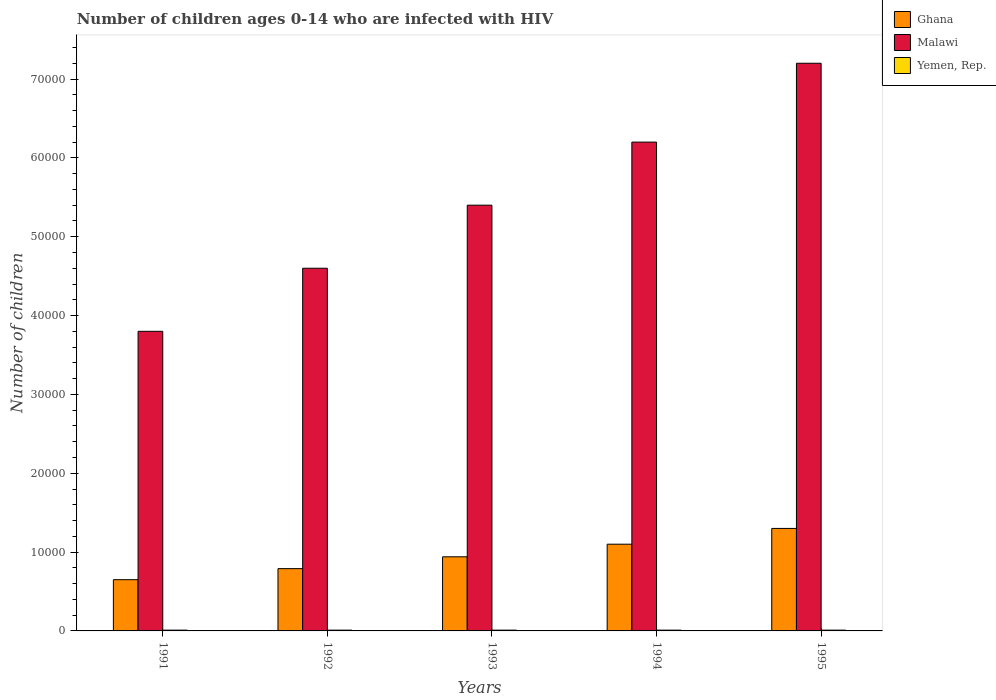How many different coloured bars are there?
Ensure brevity in your answer.  3. Are the number of bars per tick equal to the number of legend labels?
Keep it short and to the point. Yes. What is the number of HIV infected children in Yemen, Rep. in 1993?
Provide a succinct answer. 100. Across all years, what is the maximum number of HIV infected children in Yemen, Rep.?
Ensure brevity in your answer.  100. Across all years, what is the minimum number of HIV infected children in Yemen, Rep.?
Offer a very short reply. 100. In which year was the number of HIV infected children in Yemen, Rep. maximum?
Keep it short and to the point. 1991. What is the total number of HIV infected children in Ghana in the graph?
Provide a short and direct response. 4.78e+04. What is the difference between the number of HIV infected children in Yemen, Rep. in 1992 and the number of HIV infected children in Malawi in 1994?
Offer a terse response. -6.19e+04. What is the average number of HIV infected children in Malawi per year?
Your answer should be very brief. 5.44e+04. In the year 1993, what is the difference between the number of HIV infected children in Malawi and number of HIV infected children in Yemen, Rep.?
Your answer should be compact. 5.39e+04. What is the ratio of the number of HIV infected children in Ghana in 1993 to that in 1994?
Ensure brevity in your answer.  0.85. Is the number of HIV infected children in Yemen, Rep. in 1992 less than that in 1995?
Provide a succinct answer. No. Is the difference between the number of HIV infected children in Malawi in 1991 and 1993 greater than the difference between the number of HIV infected children in Yemen, Rep. in 1991 and 1993?
Keep it short and to the point. No. What is the difference between the highest and the second highest number of HIV infected children in Malawi?
Make the answer very short. 10000. Is the sum of the number of HIV infected children in Malawi in 1994 and 1995 greater than the maximum number of HIV infected children in Yemen, Rep. across all years?
Your answer should be very brief. Yes. What does the 2nd bar from the right in 1991 represents?
Make the answer very short. Malawi. Are all the bars in the graph horizontal?
Provide a short and direct response. No. How many years are there in the graph?
Keep it short and to the point. 5. Are the values on the major ticks of Y-axis written in scientific E-notation?
Your answer should be compact. No. Does the graph contain any zero values?
Ensure brevity in your answer.  No. How many legend labels are there?
Offer a terse response. 3. How are the legend labels stacked?
Provide a succinct answer. Vertical. What is the title of the graph?
Offer a terse response. Number of children ages 0-14 who are infected with HIV. What is the label or title of the Y-axis?
Your response must be concise. Number of children. What is the Number of children in Ghana in 1991?
Your answer should be very brief. 6500. What is the Number of children of Malawi in 1991?
Your answer should be compact. 3.80e+04. What is the Number of children of Yemen, Rep. in 1991?
Ensure brevity in your answer.  100. What is the Number of children of Ghana in 1992?
Ensure brevity in your answer.  7900. What is the Number of children of Malawi in 1992?
Offer a terse response. 4.60e+04. What is the Number of children in Yemen, Rep. in 1992?
Give a very brief answer. 100. What is the Number of children of Ghana in 1993?
Your answer should be very brief. 9400. What is the Number of children in Malawi in 1993?
Give a very brief answer. 5.40e+04. What is the Number of children in Yemen, Rep. in 1993?
Keep it short and to the point. 100. What is the Number of children in Ghana in 1994?
Ensure brevity in your answer.  1.10e+04. What is the Number of children of Malawi in 1994?
Ensure brevity in your answer.  6.20e+04. What is the Number of children of Ghana in 1995?
Your answer should be compact. 1.30e+04. What is the Number of children in Malawi in 1995?
Keep it short and to the point. 7.20e+04. What is the Number of children in Yemen, Rep. in 1995?
Keep it short and to the point. 100. Across all years, what is the maximum Number of children of Ghana?
Your answer should be compact. 1.30e+04. Across all years, what is the maximum Number of children of Malawi?
Make the answer very short. 7.20e+04. Across all years, what is the minimum Number of children of Ghana?
Offer a terse response. 6500. Across all years, what is the minimum Number of children in Malawi?
Provide a succinct answer. 3.80e+04. Across all years, what is the minimum Number of children of Yemen, Rep.?
Provide a short and direct response. 100. What is the total Number of children of Ghana in the graph?
Your response must be concise. 4.78e+04. What is the total Number of children in Malawi in the graph?
Provide a short and direct response. 2.72e+05. What is the total Number of children of Yemen, Rep. in the graph?
Provide a succinct answer. 500. What is the difference between the Number of children in Ghana in 1991 and that in 1992?
Give a very brief answer. -1400. What is the difference between the Number of children in Malawi in 1991 and that in 1992?
Provide a short and direct response. -8000. What is the difference between the Number of children in Ghana in 1991 and that in 1993?
Your answer should be compact. -2900. What is the difference between the Number of children of Malawi in 1991 and that in 1993?
Your answer should be very brief. -1.60e+04. What is the difference between the Number of children of Ghana in 1991 and that in 1994?
Provide a short and direct response. -4500. What is the difference between the Number of children of Malawi in 1991 and that in 1994?
Offer a terse response. -2.40e+04. What is the difference between the Number of children of Yemen, Rep. in 1991 and that in 1994?
Your answer should be very brief. 0. What is the difference between the Number of children of Ghana in 1991 and that in 1995?
Your answer should be compact. -6500. What is the difference between the Number of children in Malawi in 1991 and that in 1995?
Make the answer very short. -3.40e+04. What is the difference between the Number of children in Ghana in 1992 and that in 1993?
Offer a very short reply. -1500. What is the difference between the Number of children of Malawi in 1992 and that in 1993?
Your response must be concise. -8000. What is the difference between the Number of children of Yemen, Rep. in 1992 and that in 1993?
Provide a short and direct response. 0. What is the difference between the Number of children of Ghana in 1992 and that in 1994?
Your answer should be compact. -3100. What is the difference between the Number of children in Malawi in 1992 and that in 1994?
Provide a short and direct response. -1.60e+04. What is the difference between the Number of children of Yemen, Rep. in 1992 and that in 1994?
Give a very brief answer. 0. What is the difference between the Number of children in Ghana in 1992 and that in 1995?
Provide a short and direct response. -5100. What is the difference between the Number of children of Malawi in 1992 and that in 1995?
Your response must be concise. -2.60e+04. What is the difference between the Number of children of Yemen, Rep. in 1992 and that in 1995?
Ensure brevity in your answer.  0. What is the difference between the Number of children of Ghana in 1993 and that in 1994?
Provide a short and direct response. -1600. What is the difference between the Number of children in Malawi in 1993 and that in 1994?
Your answer should be compact. -8000. What is the difference between the Number of children in Yemen, Rep. in 1993 and that in 1994?
Give a very brief answer. 0. What is the difference between the Number of children in Ghana in 1993 and that in 1995?
Ensure brevity in your answer.  -3600. What is the difference between the Number of children in Malawi in 1993 and that in 1995?
Keep it short and to the point. -1.80e+04. What is the difference between the Number of children of Yemen, Rep. in 1993 and that in 1995?
Ensure brevity in your answer.  0. What is the difference between the Number of children of Ghana in 1994 and that in 1995?
Offer a terse response. -2000. What is the difference between the Number of children in Malawi in 1994 and that in 1995?
Provide a succinct answer. -10000. What is the difference between the Number of children in Yemen, Rep. in 1994 and that in 1995?
Keep it short and to the point. 0. What is the difference between the Number of children of Ghana in 1991 and the Number of children of Malawi in 1992?
Keep it short and to the point. -3.95e+04. What is the difference between the Number of children in Ghana in 1991 and the Number of children in Yemen, Rep. in 1992?
Make the answer very short. 6400. What is the difference between the Number of children in Malawi in 1991 and the Number of children in Yemen, Rep. in 1992?
Offer a terse response. 3.79e+04. What is the difference between the Number of children of Ghana in 1991 and the Number of children of Malawi in 1993?
Provide a short and direct response. -4.75e+04. What is the difference between the Number of children in Ghana in 1991 and the Number of children in Yemen, Rep. in 1993?
Offer a terse response. 6400. What is the difference between the Number of children of Malawi in 1991 and the Number of children of Yemen, Rep. in 1993?
Give a very brief answer. 3.79e+04. What is the difference between the Number of children in Ghana in 1991 and the Number of children in Malawi in 1994?
Your answer should be very brief. -5.55e+04. What is the difference between the Number of children of Ghana in 1991 and the Number of children of Yemen, Rep. in 1994?
Your answer should be compact. 6400. What is the difference between the Number of children of Malawi in 1991 and the Number of children of Yemen, Rep. in 1994?
Give a very brief answer. 3.79e+04. What is the difference between the Number of children of Ghana in 1991 and the Number of children of Malawi in 1995?
Offer a terse response. -6.55e+04. What is the difference between the Number of children of Ghana in 1991 and the Number of children of Yemen, Rep. in 1995?
Offer a very short reply. 6400. What is the difference between the Number of children in Malawi in 1991 and the Number of children in Yemen, Rep. in 1995?
Ensure brevity in your answer.  3.79e+04. What is the difference between the Number of children of Ghana in 1992 and the Number of children of Malawi in 1993?
Your response must be concise. -4.61e+04. What is the difference between the Number of children in Ghana in 1992 and the Number of children in Yemen, Rep. in 1993?
Keep it short and to the point. 7800. What is the difference between the Number of children in Malawi in 1992 and the Number of children in Yemen, Rep. in 1993?
Offer a very short reply. 4.59e+04. What is the difference between the Number of children in Ghana in 1992 and the Number of children in Malawi in 1994?
Offer a terse response. -5.41e+04. What is the difference between the Number of children in Ghana in 1992 and the Number of children in Yemen, Rep. in 1994?
Provide a succinct answer. 7800. What is the difference between the Number of children of Malawi in 1992 and the Number of children of Yemen, Rep. in 1994?
Offer a very short reply. 4.59e+04. What is the difference between the Number of children in Ghana in 1992 and the Number of children in Malawi in 1995?
Offer a very short reply. -6.41e+04. What is the difference between the Number of children in Ghana in 1992 and the Number of children in Yemen, Rep. in 1995?
Your answer should be very brief. 7800. What is the difference between the Number of children in Malawi in 1992 and the Number of children in Yemen, Rep. in 1995?
Offer a very short reply. 4.59e+04. What is the difference between the Number of children in Ghana in 1993 and the Number of children in Malawi in 1994?
Offer a terse response. -5.26e+04. What is the difference between the Number of children of Ghana in 1993 and the Number of children of Yemen, Rep. in 1994?
Your answer should be very brief. 9300. What is the difference between the Number of children of Malawi in 1993 and the Number of children of Yemen, Rep. in 1994?
Keep it short and to the point. 5.39e+04. What is the difference between the Number of children of Ghana in 1993 and the Number of children of Malawi in 1995?
Provide a succinct answer. -6.26e+04. What is the difference between the Number of children in Ghana in 1993 and the Number of children in Yemen, Rep. in 1995?
Provide a short and direct response. 9300. What is the difference between the Number of children of Malawi in 1993 and the Number of children of Yemen, Rep. in 1995?
Your answer should be very brief. 5.39e+04. What is the difference between the Number of children of Ghana in 1994 and the Number of children of Malawi in 1995?
Keep it short and to the point. -6.10e+04. What is the difference between the Number of children of Ghana in 1994 and the Number of children of Yemen, Rep. in 1995?
Your answer should be compact. 1.09e+04. What is the difference between the Number of children of Malawi in 1994 and the Number of children of Yemen, Rep. in 1995?
Your answer should be very brief. 6.19e+04. What is the average Number of children of Ghana per year?
Offer a terse response. 9560. What is the average Number of children in Malawi per year?
Keep it short and to the point. 5.44e+04. In the year 1991, what is the difference between the Number of children in Ghana and Number of children in Malawi?
Your answer should be compact. -3.15e+04. In the year 1991, what is the difference between the Number of children in Ghana and Number of children in Yemen, Rep.?
Provide a short and direct response. 6400. In the year 1991, what is the difference between the Number of children in Malawi and Number of children in Yemen, Rep.?
Make the answer very short. 3.79e+04. In the year 1992, what is the difference between the Number of children of Ghana and Number of children of Malawi?
Ensure brevity in your answer.  -3.81e+04. In the year 1992, what is the difference between the Number of children in Ghana and Number of children in Yemen, Rep.?
Keep it short and to the point. 7800. In the year 1992, what is the difference between the Number of children of Malawi and Number of children of Yemen, Rep.?
Give a very brief answer. 4.59e+04. In the year 1993, what is the difference between the Number of children in Ghana and Number of children in Malawi?
Provide a short and direct response. -4.46e+04. In the year 1993, what is the difference between the Number of children in Ghana and Number of children in Yemen, Rep.?
Your answer should be very brief. 9300. In the year 1993, what is the difference between the Number of children of Malawi and Number of children of Yemen, Rep.?
Your answer should be compact. 5.39e+04. In the year 1994, what is the difference between the Number of children in Ghana and Number of children in Malawi?
Your answer should be very brief. -5.10e+04. In the year 1994, what is the difference between the Number of children in Ghana and Number of children in Yemen, Rep.?
Offer a terse response. 1.09e+04. In the year 1994, what is the difference between the Number of children of Malawi and Number of children of Yemen, Rep.?
Keep it short and to the point. 6.19e+04. In the year 1995, what is the difference between the Number of children of Ghana and Number of children of Malawi?
Ensure brevity in your answer.  -5.90e+04. In the year 1995, what is the difference between the Number of children of Ghana and Number of children of Yemen, Rep.?
Give a very brief answer. 1.29e+04. In the year 1995, what is the difference between the Number of children in Malawi and Number of children in Yemen, Rep.?
Offer a very short reply. 7.19e+04. What is the ratio of the Number of children of Ghana in 1991 to that in 1992?
Offer a very short reply. 0.82. What is the ratio of the Number of children of Malawi in 1991 to that in 1992?
Provide a succinct answer. 0.83. What is the ratio of the Number of children in Yemen, Rep. in 1991 to that in 1992?
Your answer should be very brief. 1. What is the ratio of the Number of children in Ghana in 1991 to that in 1993?
Make the answer very short. 0.69. What is the ratio of the Number of children in Malawi in 1991 to that in 1993?
Give a very brief answer. 0.7. What is the ratio of the Number of children of Yemen, Rep. in 1991 to that in 1993?
Your response must be concise. 1. What is the ratio of the Number of children of Ghana in 1991 to that in 1994?
Provide a short and direct response. 0.59. What is the ratio of the Number of children of Malawi in 1991 to that in 1994?
Your response must be concise. 0.61. What is the ratio of the Number of children of Malawi in 1991 to that in 1995?
Offer a terse response. 0.53. What is the ratio of the Number of children in Yemen, Rep. in 1991 to that in 1995?
Give a very brief answer. 1. What is the ratio of the Number of children in Ghana in 1992 to that in 1993?
Offer a very short reply. 0.84. What is the ratio of the Number of children in Malawi in 1992 to that in 1993?
Offer a very short reply. 0.85. What is the ratio of the Number of children in Ghana in 1992 to that in 1994?
Provide a succinct answer. 0.72. What is the ratio of the Number of children in Malawi in 1992 to that in 1994?
Provide a short and direct response. 0.74. What is the ratio of the Number of children in Yemen, Rep. in 1992 to that in 1994?
Your answer should be compact. 1. What is the ratio of the Number of children of Ghana in 1992 to that in 1995?
Offer a very short reply. 0.61. What is the ratio of the Number of children in Malawi in 1992 to that in 1995?
Provide a succinct answer. 0.64. What is the ratio of the Number of children of Yemen, Rep. in 1992 to that in 1995?
Provide a succinct answer. 1. What is the ratio of the Number of children of Ghana in 1993 to that in 1994?
Keep it short and to the point. 0.85. What is the ratio of the Number of children of Malawi in 1993 to that in 1994?
Your answer should be compact. 0.87. What is the ratio of the Number of children in Yemen, Rep. in 1993 to that in 1994?
Your answer should be compact. 1. What is the ratio of the Number of children of Ghana in 1993 to that in 1995?
Your response must be concise. 0.72. What is the ratio of the Number of children in Malawi in 1993 to that in 1995?
Provide a succinct answer. 0.75. What is the ratio of the Number of children of Ghana in 1994 to that in 1995?
Your response must be concise. 0.85. What is the ratio of the Number of children in Malawi in 1994 to that in 1995?
Your answer should be very brief. 0.86. What is the ratio of the Number of children in Yemen, Rep. in 1994 to that in 1995?
Your answer should be very brief. 1. What is the difference between the highest and the second highest Number of children in Ghana?
Keep it short and to the point. 2000. What is the difference between the highest and the second highest Number of children of Malawi?
Your response must be concise. 10000. What is the difference between the highest and the lowest Number of children of Ghana?
Give a very brief answer. 6500. What is the difference between the highest and the lowest Number of children in Malawi?
Keep it short and to the point. 3.40e+04. What is the difference between the highest and the lowest Number of children in Yemen, Rep.?
Your answer should be very brief. 0. 